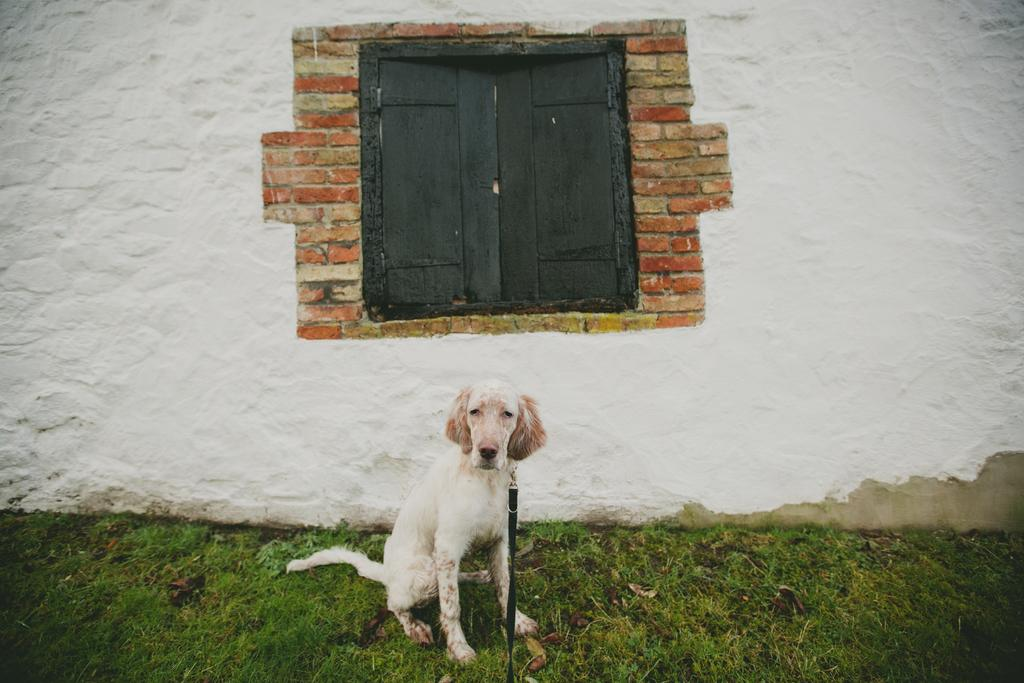What type of animal is in the image? There is a dog in the image. What is the dog wearing? The dog is wearing a belt. What is the ground covered with in the image? There is grass on the ground in the image. What can be seen in the background of the image? There is a wall with windows in the background of the image. What type of base is the dog standing on in the image? There is no base mentioned in the image; the dog is standing on grass. Is there a maid present in the image? There is no mention of a maid in the image; it only features a dog. 